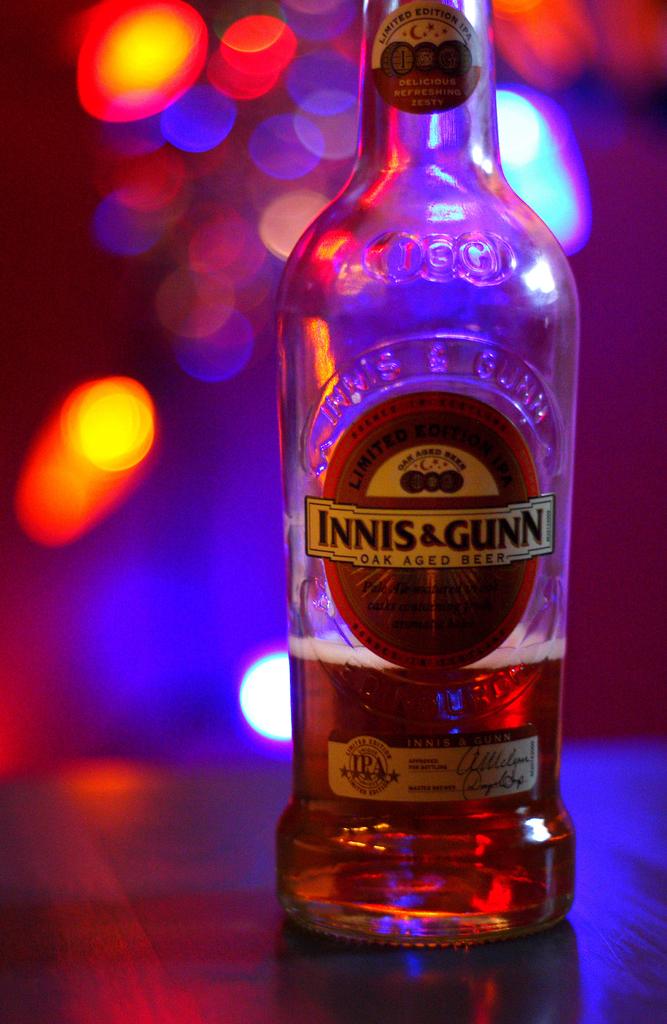Is this alcohol?
Give a very brief answer. Yes. What brand is this?
Keep it short and to the point. Innis & gunn. 